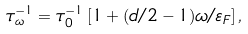<formula> <loc_0><loc_0><loc_500><loc_500>\tau _ { \omega } ^ { - 1 } = \tau _ { 0 } ^ { - 1 } \left [ 1 + ( d / 2 - 1 ) \omega / \varepsilon _ { F } \right ] ,</formula> 